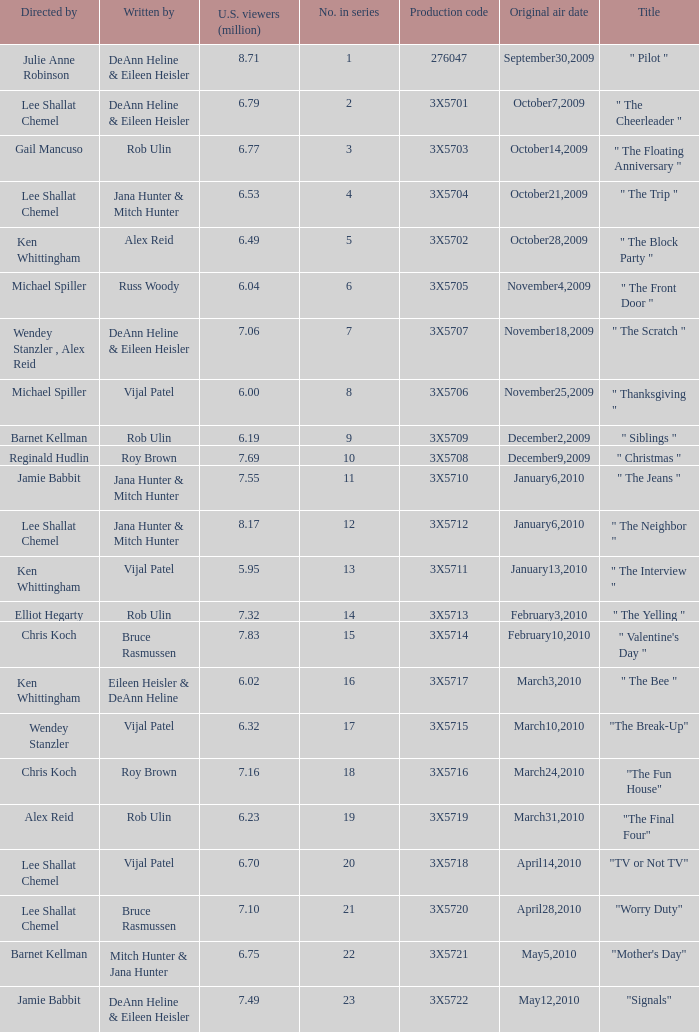How many directors got 6.79 million U.S. viewers from their episodes? 1.0. 